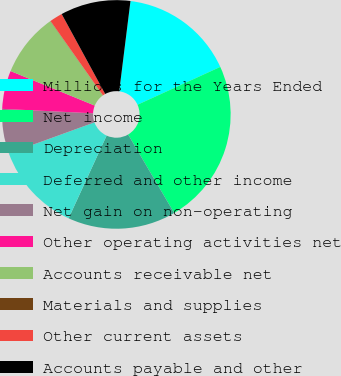<chart> <loc_0><loc_0><loc_500><loc_500><pie_chart><fcel>Millions for the Years Ended<fcel>Net income<fcel>Depreciation<fcel>Deferred and other income<fcel>Net gain on non-operating<fcel>Other operating activities net<fcel>Accounts receivable net<fcel>Materials and supplies<fcel>Other current assets<fcel>Accounts payable and other<nl><fcel>16.2%<fcel>23.38%<fcel>15.3%<fcel>12.6%<fcel>6.32%<fcel>5.42%<fcel>9.01%<fcel>0.03%<fcel>1.83%<fcel>9.91%<nl></chart> 